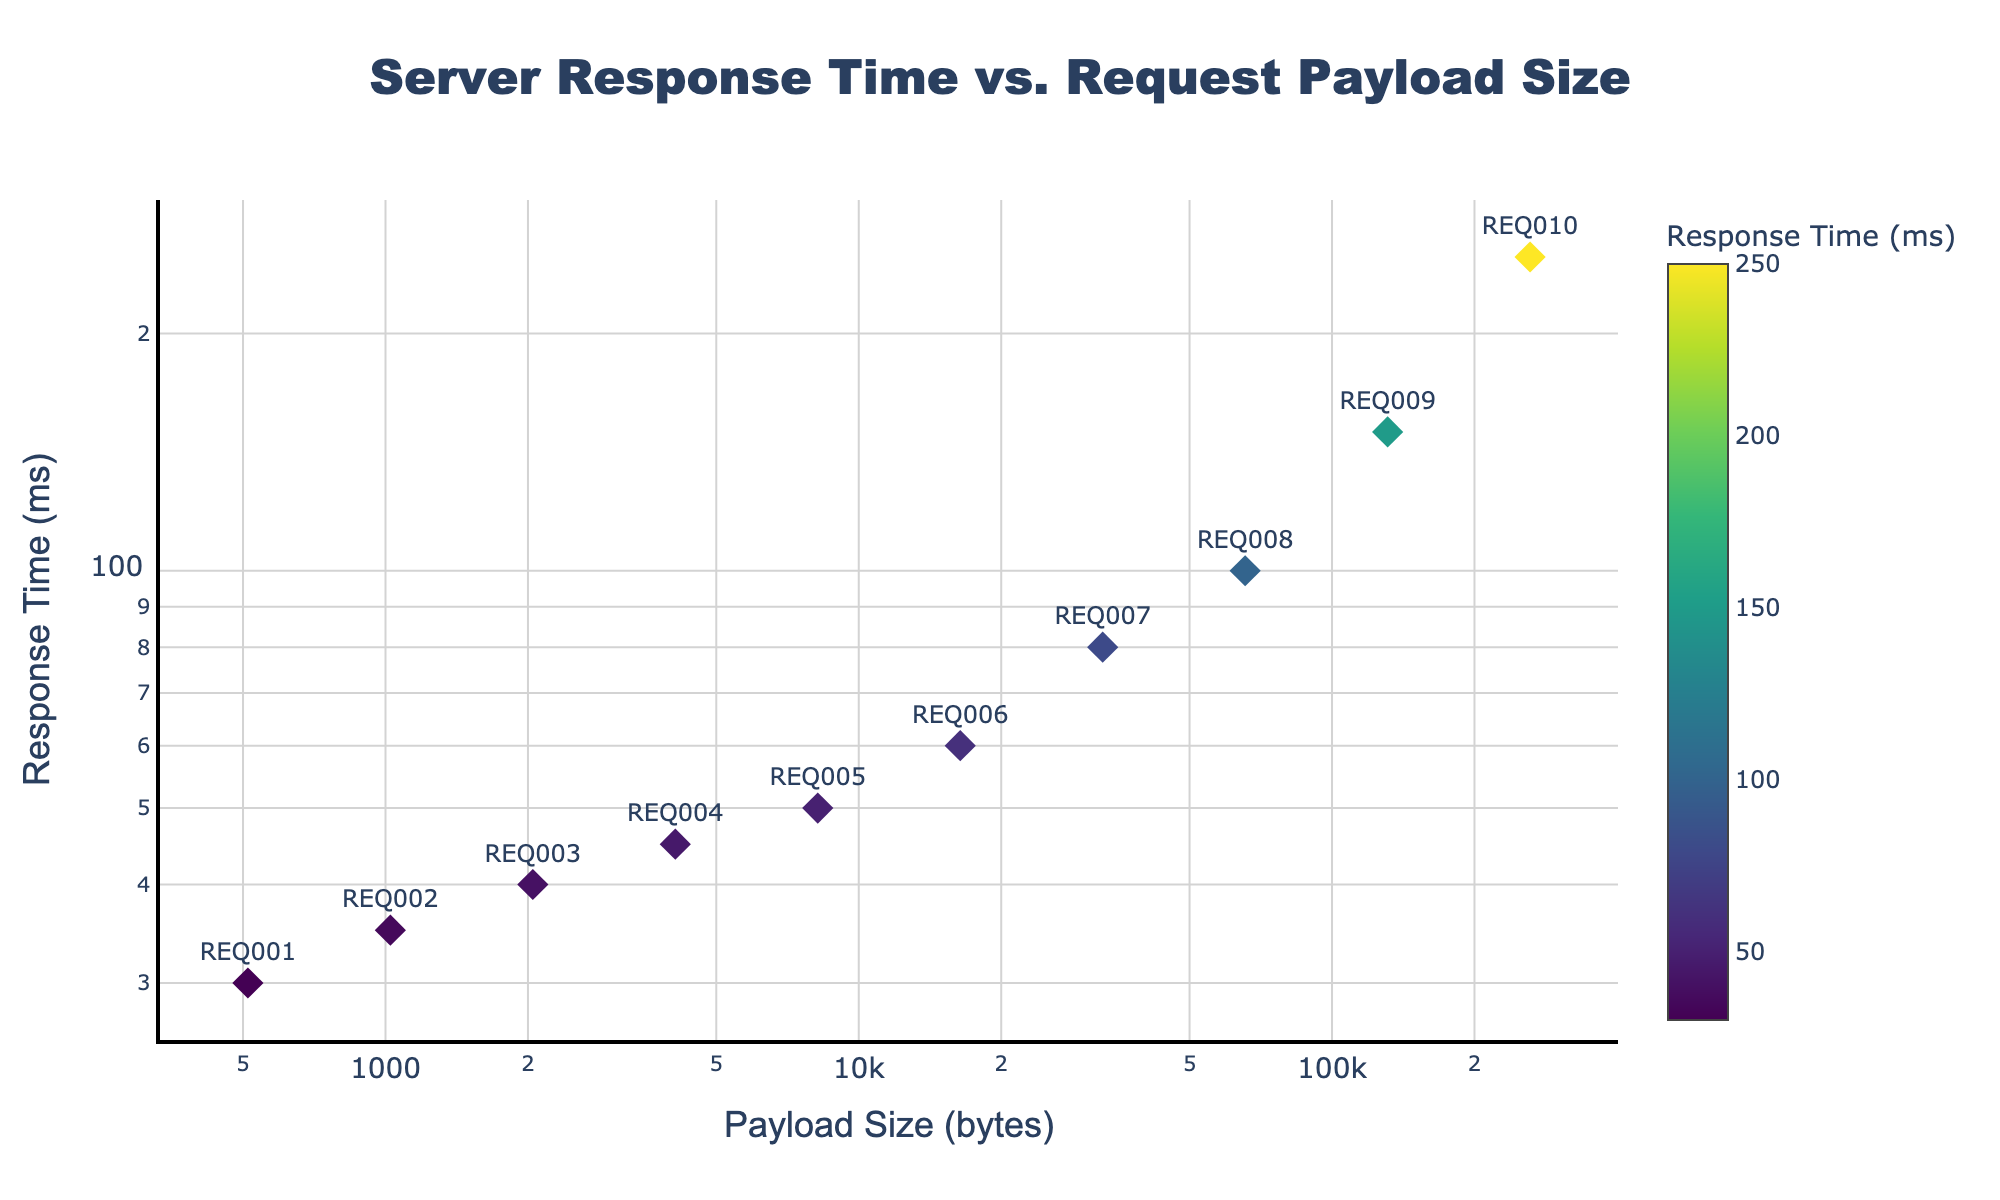What's the title of the scatter plot? The title of the scatter plot is typically found at the top center of the plot. This plot's title is clearly visible and reads "Server Response Time vs. Request Payload Size."
Answer: Server Response Time vs. Request Payload Size What do the x and y axes represent? The x-axis represents the "Payload Size (bytes)," and the y-axis represents the "Response Time (ms)." These labels are found right next to the respective axes.
Answer: Payload Size (bytes) and Response Time (ms) How many data points are in the scatter plot? To determine the number of data points, count the number of markers or labels present in the plot. There are 10 markers each corresponding to a unique request ID.
Answer: 10 What is the general trend observed in the scatter plot? The general trend can be observed by the position of the markers. As the payload size increases along the x-axis, the response time also increases along the y-axis, indicating a positive correlation between payload size and response time.
Answer: Positive correlation Which request has the highest response time and what is its payload size? The request with the highest response time has the marker placed highest on the y-axis. The marker shows that "REQ010" has the highest response time of 250 ms with a payload size of 262144 bytes.
Answer: REQ010, 262144 bytes Which request has the smallest payload size and what is the response time for this request? The smallest payload size will be the leftmost marker on the x-axis. The marker shows that "REQ001" has the smallest payload size of 512 bytes with a response time of 30 ms.
Answer: REQ001, 30 ms What is the response time range for requests with payload sizes between 1024 bytes and 8192 bytes? Identify and list the response times corresponding to the payload sizes 1024 bytes to 8192 bytes. The response times are: for 1024 bytes, 35 ms; for 2048 bytes, 40 ms; for 4096 bytes, 45 ms; and for 8192 bytes, 50 ms. The range is the difference between the highest and lowest values, which is 50 ms - 35 ms.
Answer: 15 ms Which request ID falls closest to the midpoint of the payload size range visually? The payload size range is from 512 bytes to 262144 bytes. The midpoint is approximately 131328 bytes. The marker closest to this value is "REQ009" with a payload size of 131072 bytes.
Answer: REQ009 How do the colors of the markers relate to the response times? The color of the markers is associated with the response times and follows a gradient from the Viridis color scale. Darker colors correspond to lower response times, while lighter colors correspond to higher response times, which can be confirmed by the colorbar legend.
Answer: Darker colors for lower response times, lighter colors for higher response times What pattern do the markers follow on a log-log scale? On a log-log scale, where both axes are logarithmic, if the data follows a pattern it likely indicates a power-law relationship. The markers appear to form a roughly straight line, suggesting a power-law relationship between payload size and response time.
Answer: Power-law relationship 